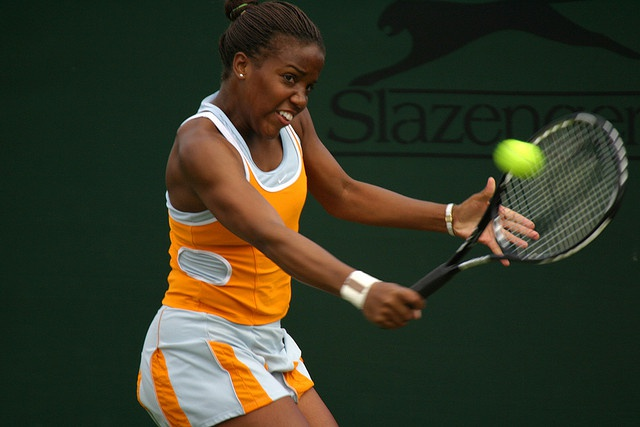Describe the objects in this image and their specific colors. I can see people in black, maroon, and brown tones, tennis racket in black, gray, and darkgreen tones, and sports ball in black, yellow, lightgreen, and olive tones in this image. 